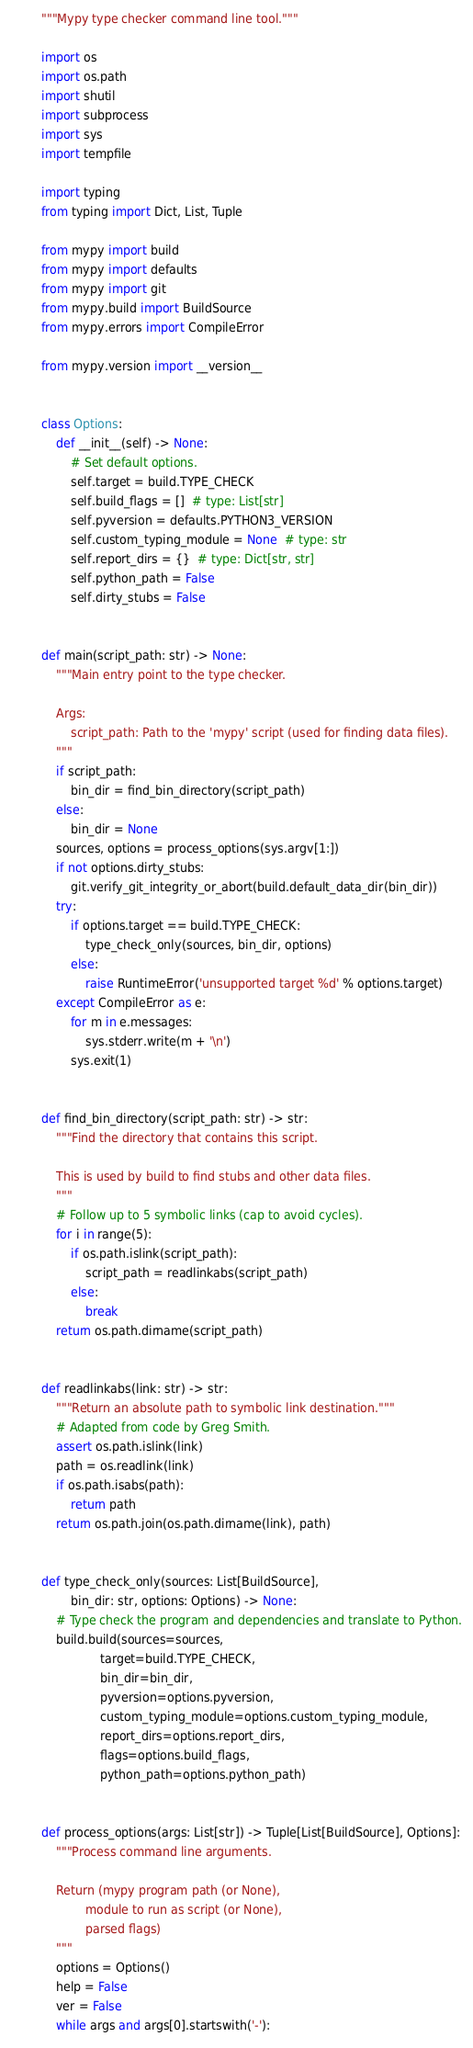<code> <loc_0><loc_0><loc_500><loc_500><_Python_>"""Mypy type checker command line tool."""

import os
import os.path
import shutil
import subprocess
import sys
import tempfile

import typing
from typing import Dict, List, Tuple

from mypy import build
from mypy import defaults
from mypy import git
from mypy.build import BuildSource
from mypy.errors import CompileError

from mypy.version import __version__


class Options:
    def __init__(self) -> None:
        # Set default options.
        self.target = build.TYPE_CHECK
        self.build_flags = []  # type: List[str]
        self.pyversion = defaults.PYTHON3_VERSION
        self.custom_typing_module = None  # type: str
        self.report_dirs = {}  # type: Dict[str, str]
        self.python_path = False
        self.dirty_stubs = False


def main(script_path: str) -> None:
    """Main entry point to the type checker.

    Args:
        script_path: Path to the 'mypy' script (used for finding data files).
    """
    if script_path:
        bin_dir = find_bin_directory(script_path)
    else:
        bin_dir = None
    sources, options = process_options(sys.argv[1:])
    if not options.dirty_stubs:
        git.verify_git_integrity_or_abort(build.default_data_dir(bin_dir))
    try:
        if options.target == build.TYPE_CHECK:
            type_check_only(sources, bin_dir, options)
        else:
            raise RuntimeError('unsupported target %d' % options.target)
    except CompileError as e:
        for m in e.messages:
            sys.stderr.write(m + '\n')
        sys.exit(1)


def find_bin_directory(script_path: str) -> str:
    """Find the directory that contains this script.

    This is used by build to find stubs and other data files.
    """
    # Follow up to 5 symbolic links (cap to avoid cycles).
    for i in range(5):
        if os.path.islink(script_path):
            script_path = readlinkabs(script_path)
        else:
            break
    return os.path.dirname(script_path)


def readlinkabs(link: str) -> str:
    """Return an absolute path to symbolic link destination."""
    # Adapted from code by Greg Smith.
    assert os.path.islink(link)
    path = os.readlink(link)
    if os.path.isabs(path):
        return path
    return os.path.join(os.path.dirname(link), path)


def type_check_only(sources: List[BuildSource],
        bin_dir: str, options: Options) -> None:
    # Type check the program and dependencies and translate to Python.
    build.build(sources=sources,
                target=build.TYPE_CHECK,
                bin_dir=bin_dir,
                pyversion=options.pyversion,
                custom_typing_module=options.custom_typing_module,
                report_dirs=options.report_dirs,
                flags=options.build_flags,
                python_path=options.python_path)


def process_options(args: List[str]) -> Tuple[List[BuildSource], Options]:
    """Process command line arguments.

    Return (mypy program path (or None),
            module to run as script (or None),
            parsed flags)
    """
    options = Options()
    help = False
    ver = False
    while args and args[0].startswith('-'):</code> 